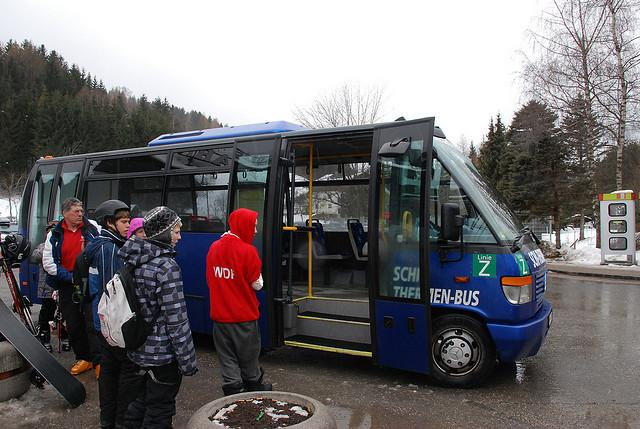Which head covering is made of the hardest material?

Choices:
A) black/white
B) pink
C) red
D) black black 